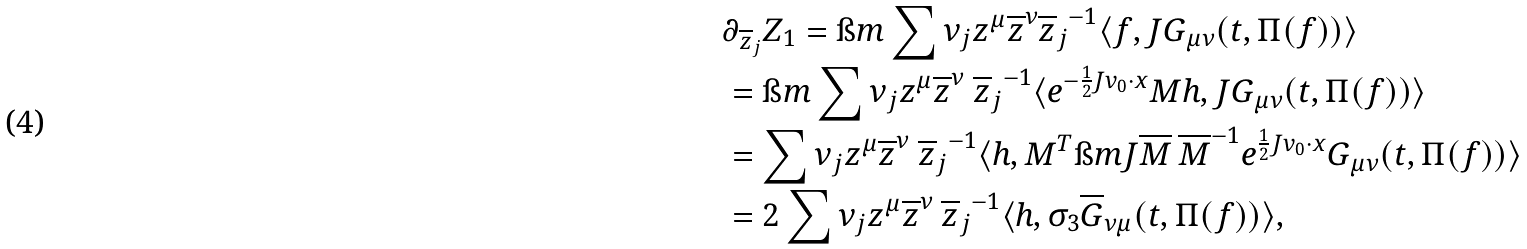<formula> <loc_0><loc_0><loc_500><loc_500>& \partial _ { \overline { z } _ { j } } Z _ { 1 } = \i m \sum \nu _ { j } { z ^ { \mu } \overline { z } ^ { \nu } } { \overline { z } _ { j } } ^ { - 1 } \langle f , J { G } _ { \mu \nu } ( t , \Pi ( f ) ) \rangle \\ & = \i m \sum \nu _ { j } { z ^ { \mu } \overline { z } ^ { \nu } } \ { \overline { z } _ { j } } ^ { - 1 } \langle e ^ { - \frac { 1 } { 2 } J v _ { 0 } \cdot x } M h , J { G } _ { \mu \nu } ( t , \Pi ( f ) ) \rangle \\ & = \sum \nu _ { j } { z ^ { \mu } \overline { z } ^ { \nu } } \ { \overline { z } _ { j } } ^ { - 1 } \langle h , M ^ { T } \i m J \overline { M } \, \overline { M } ^ { - 1 } e ^ { \frac { 1 } { 2 } J v _ { 0 } \cdot x } { G } _ { \mu \nu } ( t , \Pi ( f ) ) \rangle \\ & = 2 \sum \nu _ { j } { z ^ { \mu } \overline { z } ^ { \nu } } \ { \overline { z } _ { j } } ^ { - 1 } \langle h , \sigma _ { 3 } \overline { G } _ { \nu \mu } ( t , \Pi ( f ) ) \rangle ,</formula> 